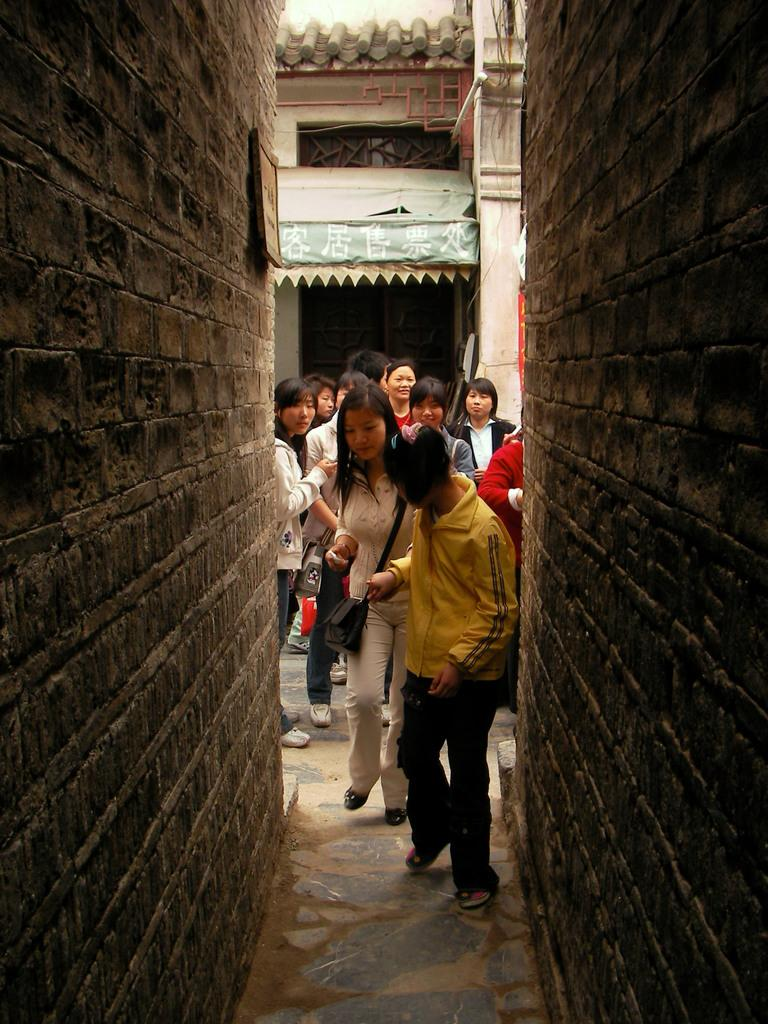Who or what can be seen in the image? There are people in the image. What are the people doing in the image? The people are standing. Where are the people located in the image? The people are between buildings. What route does the grandfather take to visit the representative in the image? There is no grandfather or representative present in the image, so it is not possible to determine a route. 